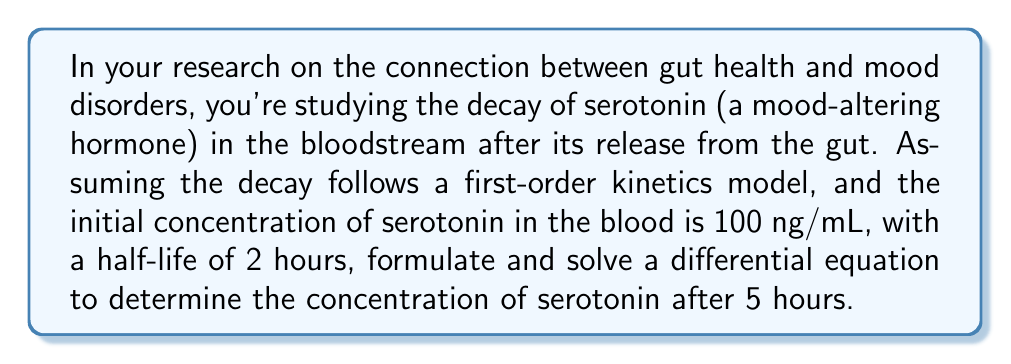Show me your answer to this math problem. Let's approach this step-by-step:

1) First, we need to set up our differential equation. Let $C(t)$ be the concentration of serotonin at time $t$. For first-order kinetics, we have:

   $$\frac{dC}{dt} = -kC$$

   where $k$ is the decay constant.

2) We're given the half-life $t_{1/2} = 2$ hours. We can use this to find $k$:

   $$k = \frac{\ln(2)}{t_{1/2}} = \frac{\ln(2)}{2} \approx 0.3466\text{ hr}^{-1}$$

3) Now our differential equation is:

   $$\frac{dC}{dt} = -0.3466C$$

4) The general solution to this equation is:

   $$C(t) = C_0e^{-0.3466t}$$

   where $C_0$ is the initial concentration.

5) We're given that $C_0 = 100$ ng/mL, so our specific solution is:

   $$C(t) = 100e^{-0.3466t}$$

6) To find the concentration after 5 hours, we simply plug in $t = 5$:

   $$C(5) = 100e^{-0.3466(5)} \approx 17.76\text{ ng/mL}$$

Thus, after 5 hours, the concentration of serotonin in the bloodstream will be approximately 17.76 ng/mL.
Answer: $17.76\text{ ng/mL}$ 